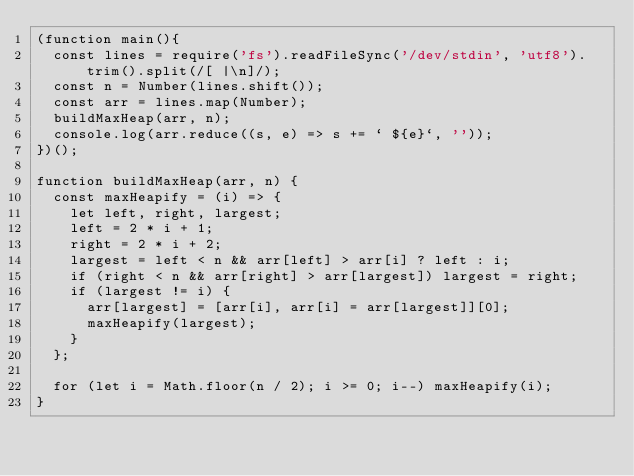<code> <loc_0><loc_0><loc_500><loc_500><_JavaScript_>(function main(){
  const lines = require('fs').readFileSync('/dev/stdin', 'utf8').trim().split(/[ |\n]/);
  const n = Number(lines.shift());
  const arr = lines.map(Number);
  buildMaxHeap(arr, n);
  console.log(arr.reduce((s, e) => s += ` ${e}`, ''));
})();

function buildMaxHeap(arr, n) {
  const maxHeapify = (i) => {
    let left, right, largest;
    left = 2 * i + 1;
    right = 2 * i + 2;
    largest = left < n && arr[left] > arr[i] ? left : i;
    if (right < n && arr[right] > arr[largest]) largest = right;
    if (largest != i) {
      arr[largest] = [arr[i], arr[i] = arr[largest]][0];
      maxHeapify(largest);
    }
  };

  for (let i = Math.floor(n / 2); i >= 0; i--) maxHeapify(i);
}

</code> 